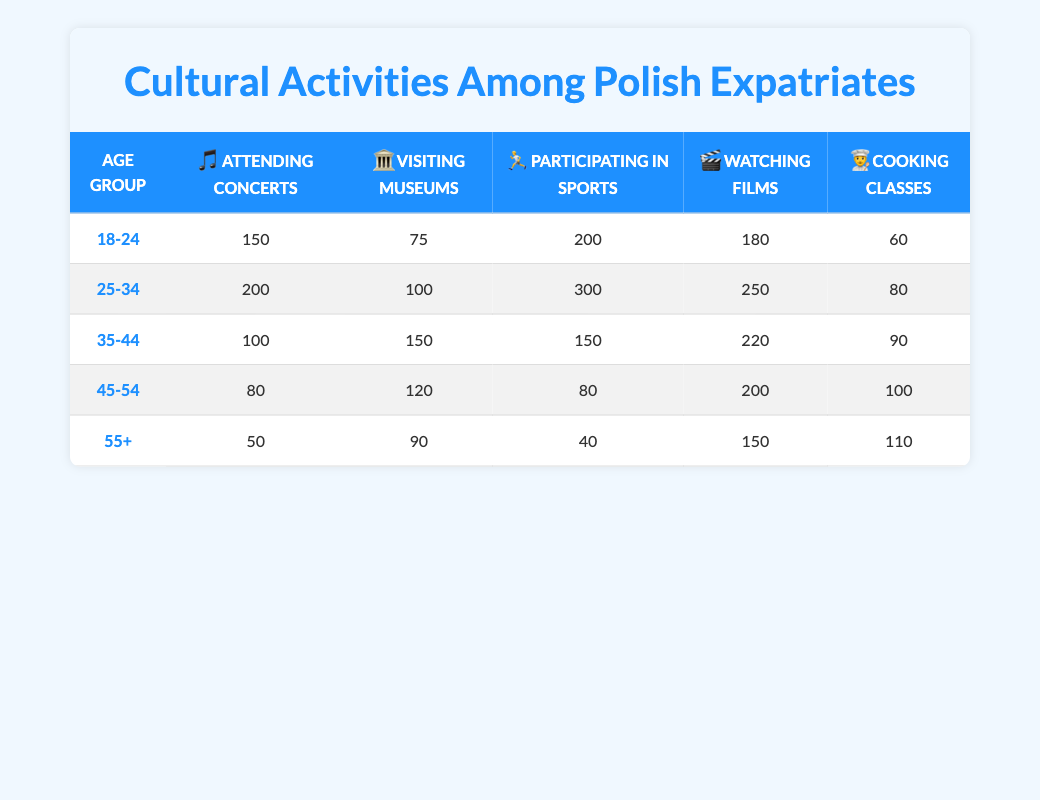What age group has the highest participation in watching films? In the table, the "Watching Films" column indicates the number of participants from each age group. The highest value is 250 for the age group 25-34.
Answer: 25-34 Which age group shows the least interest in participating in sports? The "Participating in Sports" column shows the values for each age group. The lowest value is 40 for the age group 55+.
Answer: 55+ What is the total number of participants from the age group 35-44 who enjoy cultural activities? To calculate this, we sum the values in the row for the 35-44 age group: 100 (concerts) + 150 (museums) + 150 (sports) + 220 (films) + 90 (cooking classes) = 710.
Answer: 710 Is it true that more than 100 participants from the age group 45-54 enjoy cooking classes? The table shows that the value for cooking classes in the 45-54 age group is 100. Therefore, it is not more than 100; the statement is false.
Answer: No What is the average number of participants in attending concerts across all age groups? To find this, we add the numbers of participants in attending concerts for each age group: 150 + 200 + 100 + 80 + 50 = 580. Then, since there are 5 age groups, we divide by 5: 580 / 5 = 116.
Answer: 116 Which cultural activity is most popular among the 25-34 age group? By looking at the values in the 25-34 row, we can see that "Participating in Sports" has the highest value at 300 participants, indicating it's the most popular activity for this age group.
Answer: Participating in Sports How many more people in the age group 18-24 attend concerts compared to visiting museums? For age group 18-24, 150 attend concerts while 75 visit museums. The difference is 150 - 75 = 75, indicating that 75 more people attend concerts than visit museums.
Answer: 75 Does the age group 55+ have the highest number of participants in cooking classes? In the table, the value for cooking classes in the 55+ age group is 110, while the other values in this column are 60 (18-24), 80 (25-34), 90 (35-44), and 100 (45-54). Thus, 110 is indeed the highest.
Answer: Yes 